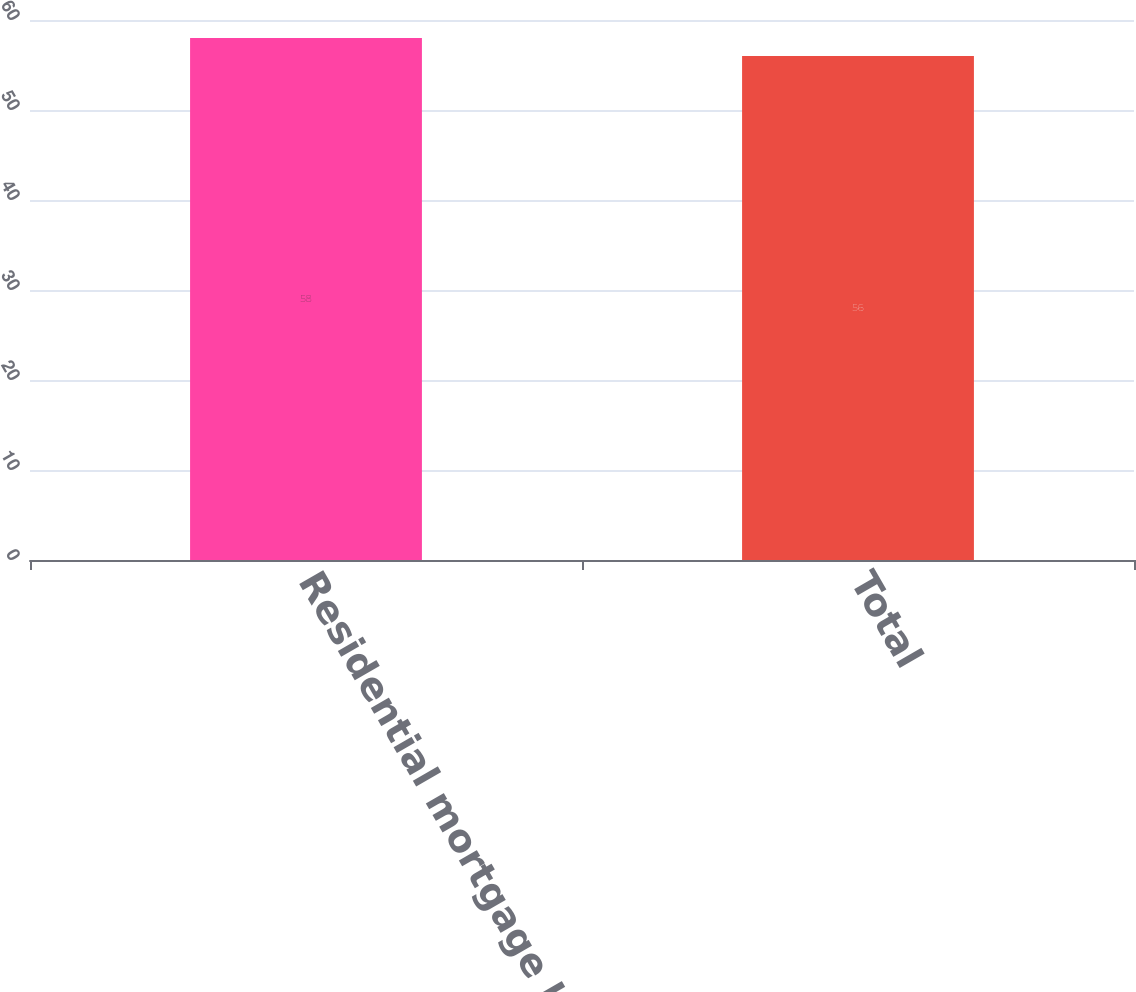Convert chart to OTSL. <chart><loc_0><loc_0><loc_500><loc_500><bar_chart><fcel>Residential mortgage backed<fcel>Total<nl><fcel>58<fcel>56<nl></chart> 